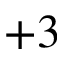<formula> <loc_0><loc_0><loc_500><loc_500>+ 3</formula> 